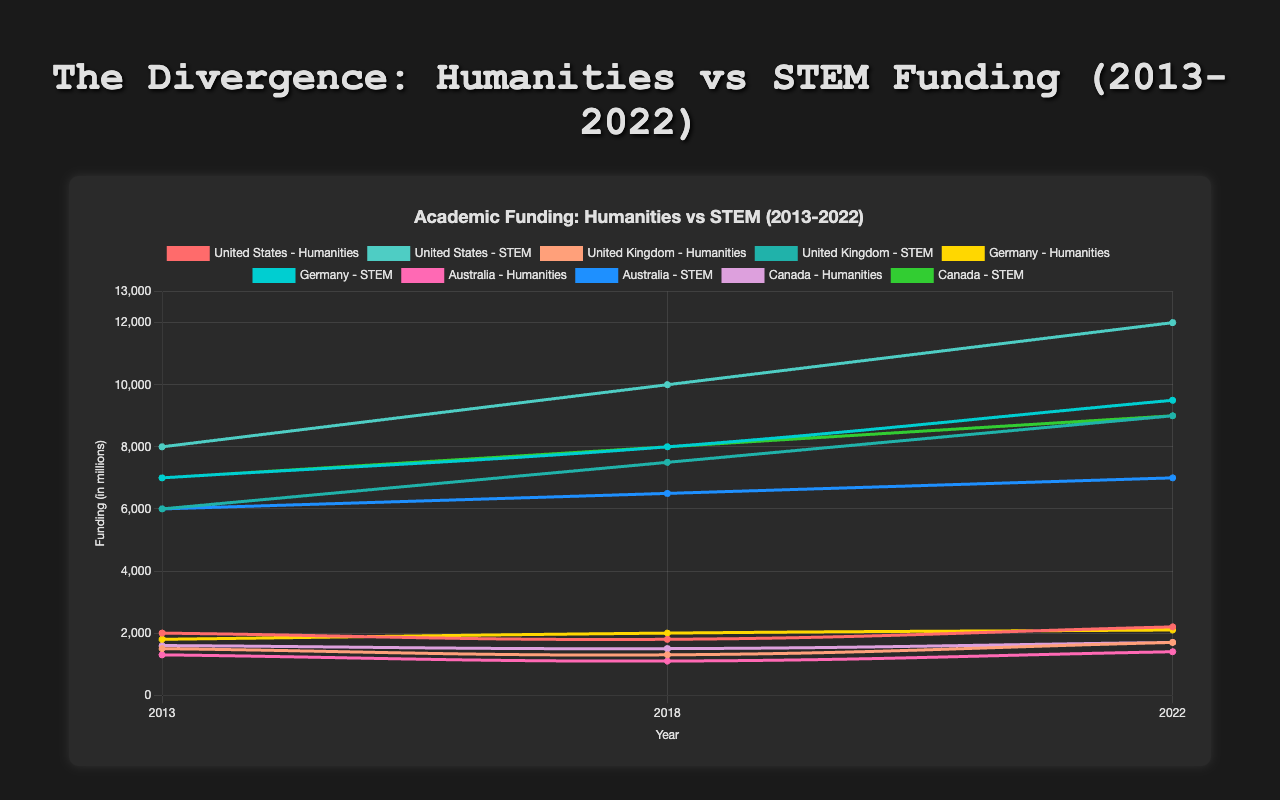Which country has the highest STEM funding in 2022? By comparing the STEM funding values for 2022 across all countries, we see that the United States has the highest funding amounting to 12000 million.
Answer: United States Is the funding for humanities increasing or decreasing in the United Kingdom from 2013 to 2022? By observing the trend for humanities funding in the United Kingdom, we see that it decreases from 1500 million in 2013 to 1300 million in 2018, but then increases to 1700 million in 2022. Overall, the funding increases from 2013 to 2022.
Answer: Increasing How much more or less is the STEM funding compared to humanities funding in Germany for the year 2018? In 2018, Germany's humanities funding is 2000 million and STEM funding is 8000 million. The difference is 8000 - 2000 = 6000 million.
Answer: 6000 million more What is the total combined funding (humanities + STEM) for Canada in 2022? Canada’s funding for humanities in 2022 is 1700 million and for STEM is 9000 million. The total combined funding is 1700 + 9000 = 10700 million.
Answer: 10700 million Which country has the largest difference in funding between STEM and humanities in 2022? Looking at the differences in funding for 2022, the United States has the most significant disparity: 12000 million (STEM) - 2200 million (humanities) = 9800 million.
Answer: United States Has humanities funding for Australia recovered to its 2013 levels by 2022? In Australia, humanities funding in 2013 was 1300 million and in 2022 it is 1400 million, which shows that the funding has not only recovered but exceeded the 2013 levels.
Answer: Yes Which country consistently shows increasing humanities funding over the ten years? Germany is the only country that shows a consistent increase in humanities funding in 2013 (1800 million), 2018 (2000 million), and 2022 (2100 million).
Answer: Germany How does the rate of increase in STEM funding for the United Kingdom from 2013 to 2022 compare to the United States for the same period? The United Kingdom's STEM funding increased from 6000 million in 2013 to 9000 million in 2022, an increase of 3000 million. The United States' STEM funding increased from 8000 million in 2013 to 12000 million in 2022, an increase of 4000 million. Thus, the United States has a higher rate of increase.
Answer: United States What is the average STEM funding for Canada over the last ten years? STEM funding for Canada is 7000 million (2013), 8000 million (2018), and 9000 million (2022). The average is (7000 + 8000 + 9000) / 3 = 8000 million.
Answer: 8000 million 